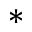Convert formula to latex. <formula><loc_0><loc_0><loc_500><loc_500>*</formula> 